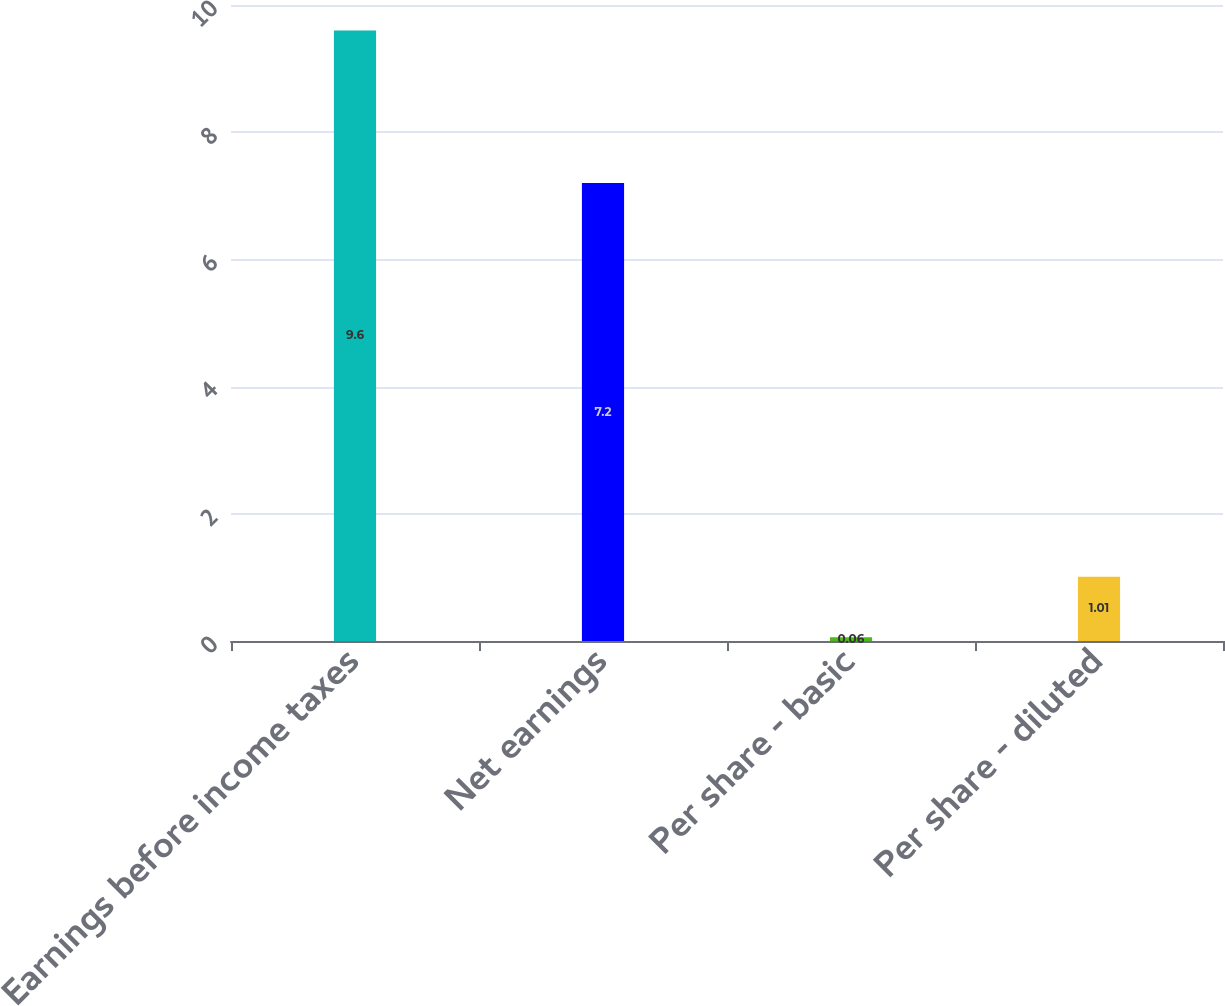Convert chart. <chart><loc_0><loc_0><loc_500><loc_500><bar_chart><fcel>Earnings before income taxes<fcel>Net earnings<fcel>Per share - basic<fcel>Per share - diluted<nl><fcel>9.6<fcel>7.2<fcel>0.06<fcel>1.01<nl></chart> 